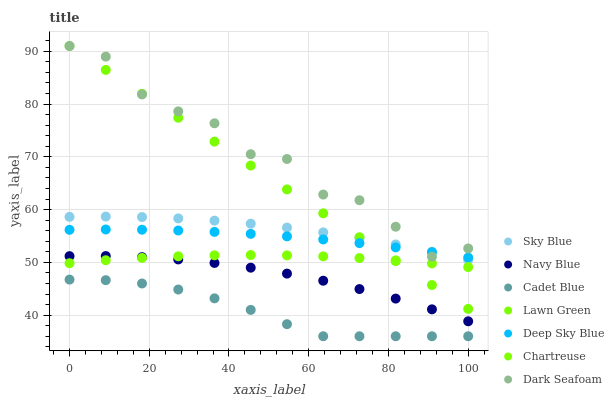Does Cadet Blue have the minimum area under the curve?
Answer yes or no. Yes. Does Dark Seafoam have the maximum area under the curve?
Answer yes or no. Yes. Does Navy Blue have the minimum area under the curve?
Answer yes or no. No. Does Navy Blue have the maximum area under the curve?
Answer yes or no. No. Is Lawn Green the smoothest?
Answer yes or no. Yes. Is Dark Seafoam the roughest?
Answer yes or no. Yes. Is Cadet Blue the smoothest?
Answer yes or no. No. Is Cadet Blue the roughest?
Answer yes or no. No. Does Cadet Blue have the lowest value?
Answer yes or no. Yes. Does Navy Blue have the lowest value?
Answer yes or no. No. Does Dark Seafoam have the highest value?
Answer yes or no. Yes. Does Navy Blue have the highest value?
Answer yes or no. No. Is Chartreuse less than Deep Sky Blue?
Answer yes or no. Yes. Is Deep Sky Blue greater than Chartreuse?
Answer yes or no. Yes. Does Lawn Green intersect Dark Seafoam?
Answer yes or no. Yes. Is Lawn Green less than Dark Seafoam?
Answer yes or no. No. Is Lawn Green greater than Dark Seafoam?
Answer yes or no. No. Does Chartreuse intersect Deep Sky Blue?
Answer yes or no. No. 